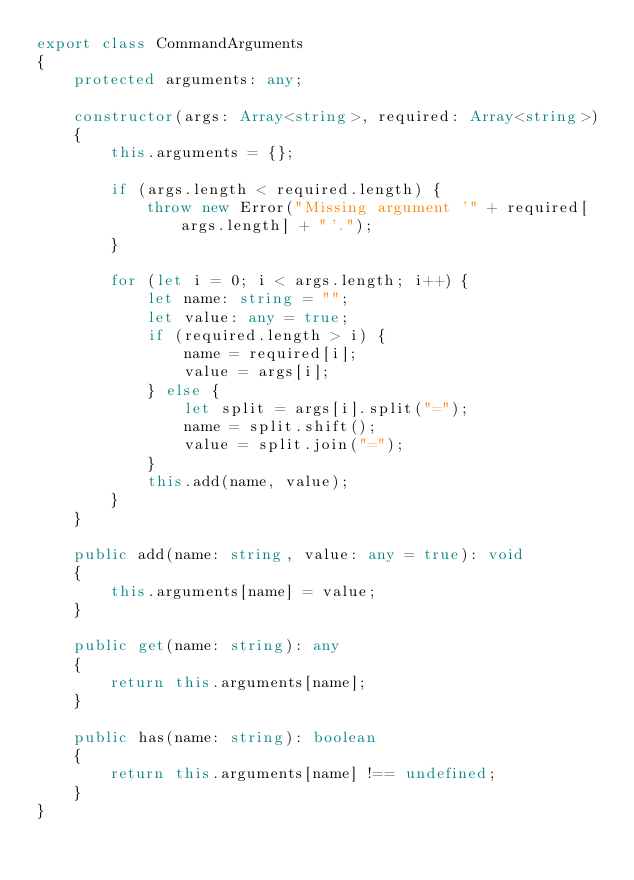Convert code to text. <code><loc_0><loc_0><loc_500><loc_500><_TypeScript_>export class CommandArguments
{
    protected arguments: any;

    constructor(args: Array<string>, required: Array<string>)
    {
        this.arguments = {};

        if (args.length < required.length) {
            throw new Error("Missing argument '" + required[args.length] + "'.");
        }

        for (let i = 0; i < args.length; i++) {
            let name: string = "";
            let value: any = true;
            if (required.length > i) {
                name = required[i];
                value = args[i];
            } else {
                let split = args[i].split("=");
                name = split.shift();
                value = split.join("=");
            }
            this.add(name, value);
        }
    }

    public add(name: string, value: any = true): void
    {
        this.arguments[name] = value;
    }

    public get(name: string): any
    {
        return this.arguments[name];
    }

    public has(name: string): boolean
    {
        return this.arguments[name] !== undefined;
    }
}</code> 